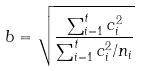<formula> <loc_0><loc_0><loc_500><loc_500>b = \sqrt { \frac { \sum _ { i = 1 } ^ { t } c _ { i } ^ { 2 } } { \sum _ { i = 1 } ^ { t } c _ { i } ^ { 2 } / n _ { i } } }</formula> 